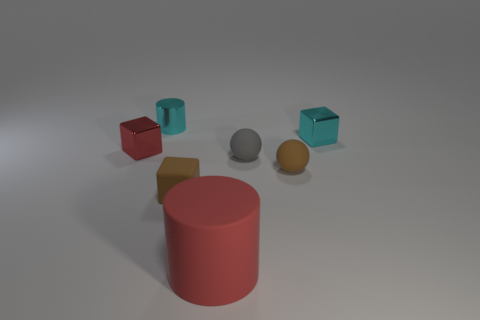What number of things are either shiny cylinders or large balls?
Give a very brief answer. 1. There is a small cyan shiny cylinder; are there any tiny red metallic blocks to the left of it?
Your response must be concise. Yes. Are there any other large cylinders made of the same material as the red cylinder?
Your answer should be very brief. No. What is the size of the cube that is the same color as the big rubber cylinder?
Provide a succinct answer. Small. How many balls are tiny rubber objects or tiny cyan metal objects?
Offer a terse response. 2. Is the number of tiny metal blocks right of the red rubber cylinder greater than the number of small matte cubes on the right side of the tiny gray sphere?
Provide a short and direct response. Yes. How many big matte things are the same color as the rubber block?
Make the answer very short. 0. There is a cylinder that is the same material as the small red thing; what is its size?
Your answer should be compact. Small. How many things are either rubber things behind the red cylinder or brown rubber cylinders?
Your response must be concise. 3. There is a tiny metal cube left of the small cyan block; is its color the same as the large thing?
Your answer should be very brief. Yes. 